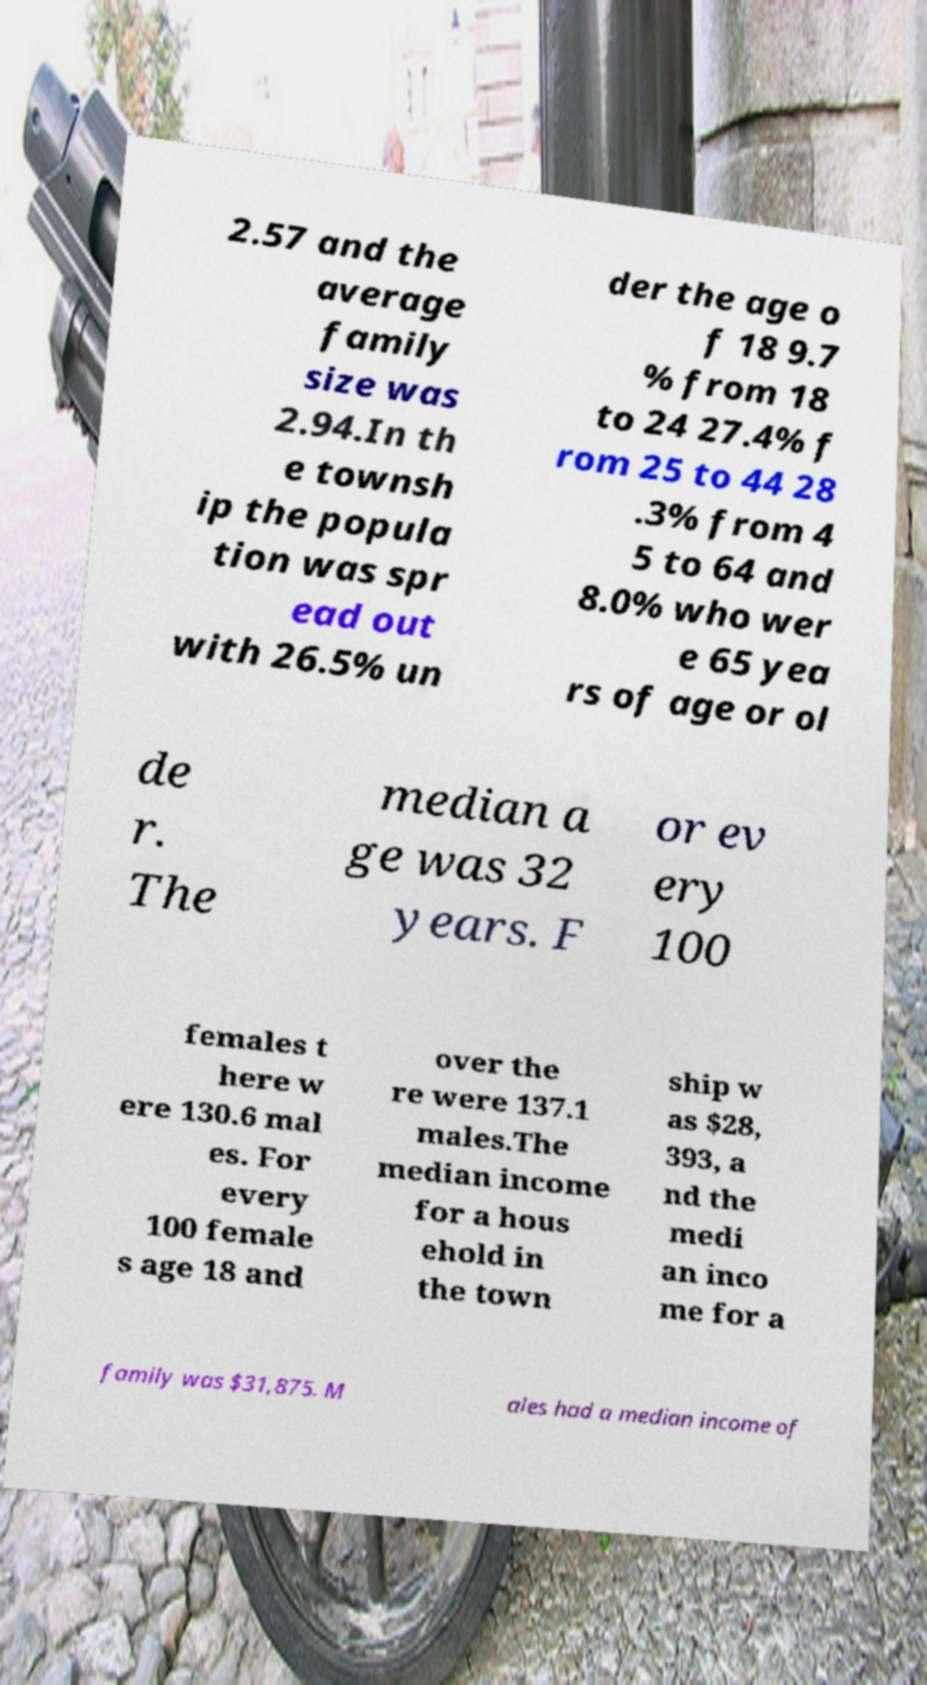I need the written content from this picture converted into text. Can you do that? 2.57 and the average family size was 2.94.In th e townsh ip the popula tion was spr ead out with 26.5% un der the age o f 18 9.7 % from 18 to 24 27.4% f rom 25 to 44 28 .3% from 4 5 to 64 and 8.0% who wer e 65 yea rs of age or ol de r. The median a ge was 32 years. F or ev ery 100 females t here w ere 130.6 mal es. For every 100 female s age 18 and over the re were 137.1 males.The median income for a hous ehold in the town ship w as $28, 393, a nd the medi an inco me for a family was $31,875. M ales had a median income of 